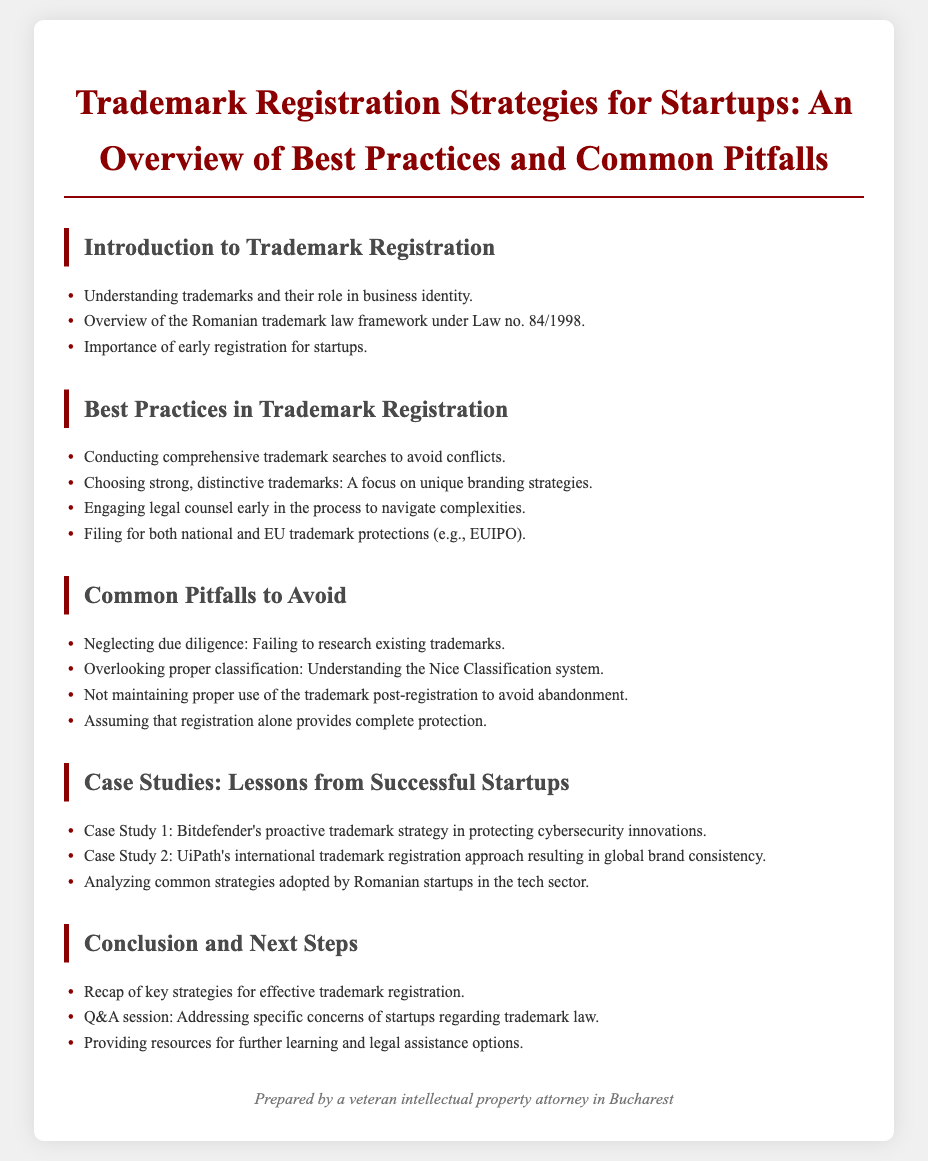What is the title of the document? The title of the document is presented at the top, which outlines the main topic.
Answer: Trademark Registration Strategies for Startups: An Overview of Best Practices and Common Pitfalls What law framework is mentioned in the introduction? The document refers to a specific law governing trademarks in Romania, which is noted in the introduction section.
Answer: Law no. 84/1998 What is the first best practice listed for trademark registration? The first best practice is outlined in the section dedicated to best practices, focusing on important preliminary actions.
Answer: Conducting comprehensive trademark searches to avoid conflicts What common pitfall is mentioned regarding trademark use? The document lists an important aspect of trademark maintenance in the section about common pitfalls.
Answer: Not maintaining proper use of the trademark post-registration to avoid abandonment Which company is cited as a successful case study in cybersecurity? The document provides examples of successful startups and mentions a specific case study related to cybersecurity.
Answer: Bitdefender's proactive trademark strategy in protecting cybersecurity innovations How many case studies are presented in the document? This information can be inferred from the section that discusses case studies as examples of effective trademark strategies.
Answer: Two case studies What classification system is referred to in common pitfalls? The document highlights a specific classification system relevant to trademark registration and classification.
Answer: Nice Classification system What type of session is included in the conclusion? The conclusion section notes a specific interactive component that addresses attendees' questions.
Answer: Q&A session: Addressing specific concerns of startups regarding trademark law 